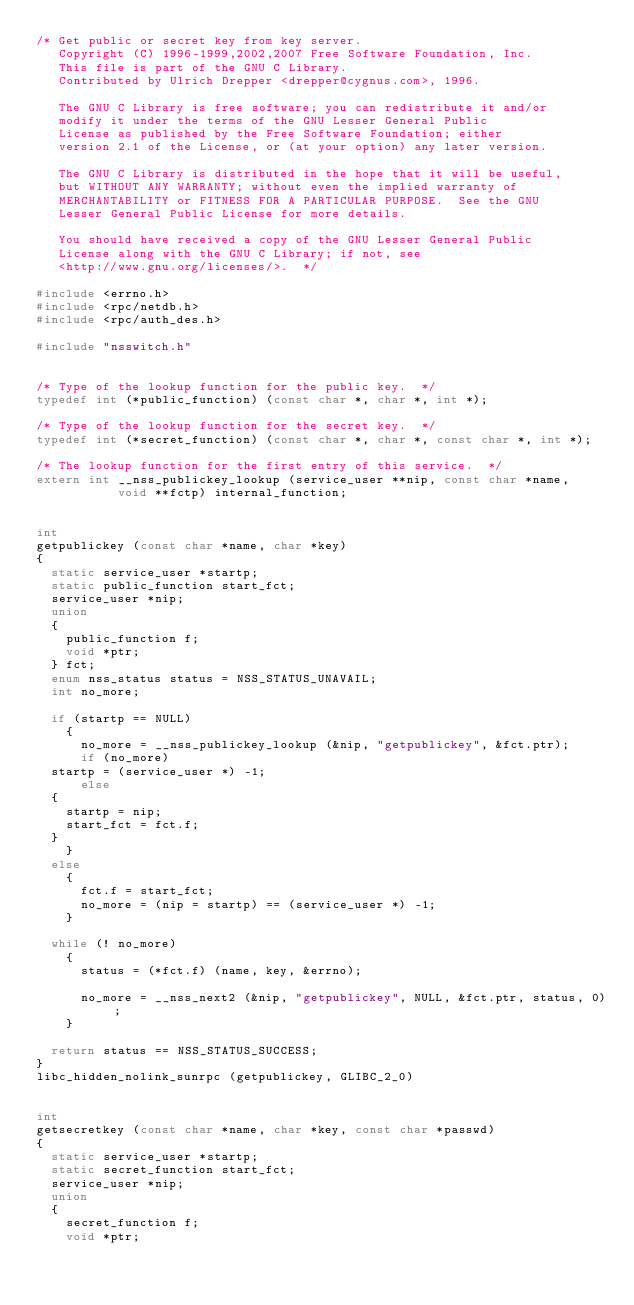Convert code to text. <code><loc_0><loc_0><loc_500><loc_500><_C_>/* Get public or secret key from key server.
   Copyright (C) 1996-1999,2002,2007 Free Software Foundation, Inc.
   This file is part of the GNU C Library.
   Contributed by Ulrich Drepper <drepper@cygnus.com>, 1996.

   The GNU C Library is free software; you can redistribute it and/or
   modify it under the terms of the GNU Lesser General Public
   License as published by the Free Software Foundation; either
   version 2.1 of the License, or (at your option) any later version.

   The GNU C Library is distributed in the hope that it will be useful,
   but WITHOUT ANY WARRANTY; without even the implied warranty of
   MERCHANTABILITY or FITNESS FOR A PARTICULAR PURPOSE.  See the GNU
   Lesser General Public License for more details.

   You should have received a copy of the GNU Lesser General Public
   License along with the GNU C Library; if not, see
   <http://www.gnu.org/licenses/>.  */

#include <errno.h>
#include <rpc/netdb.h>
#include <rpc/auth_des.h>

#include "nsswitch.h"


/* Type of the lookup function for the public key.  */
typedef int (*public_function) (const char *, char *, int *);

/* Type of the lookup function for the secret key.  */
typedef int (*secret_function) (const char *, char *, const char *, int *);

/* The lookup function for the first entry of this service.  */
extern int __nss_publickey_lookup (service_user **nip, const char *name,
				   void **fctp) internal_function;


int
getpublickey (const char *name, char *key)
{
  static service_user *startp;
  static public_function start_fct;
  service_user *nip;
  union
  {
    public_function f;
    void *ptr;
  } fct;
  enum nss_status status = NSS_STATUS_UNAVAIL;
  int no_more;

  if (startp == NULL)
    {
      no_more = __nss_publickey_lookup (&nip, "getpublickey", &fct.ptr);
      if (no_more)
	startp = (service_user *) -1;
      else
	{
	  startp = nip;
	  start_fct = fct.f;
	}
    }
  else
    {
      fct.f = start_fct;
      no_more = (nip = startp) == (service_user *) -1;
    }

  while (! no_more)
    {
      status = (*fct.f) (name, key, &errno);

      no_more = __nss_next2 (&nip, "getpublickey", NULL, &fct.ptr, status, 0);
    }

  return status == NSS_STATUS_SUCCESS;
}
libc_hidden_nolink_sunrpc (getpublickey, GLIBC_2_0)


int
getsecretkey (const char *name, char *key, const char *passwd)
{
  static service_user *startp;
  static secret_function start_fct;
  service_user *nip;
  union
  {
    secret_function f;
    void *ptr;</code> 